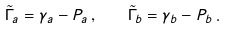Convert formula to latex. <formula><loc_0><loc_0><loc_500><loc_500>\tilde { \Gamma } _ { a } = \gamma _ { a } - P _ { a } \, , \quad \tilde { \Gamma } _ { b } = \gamma _ { b } - P _ { b } \, .</formula> 